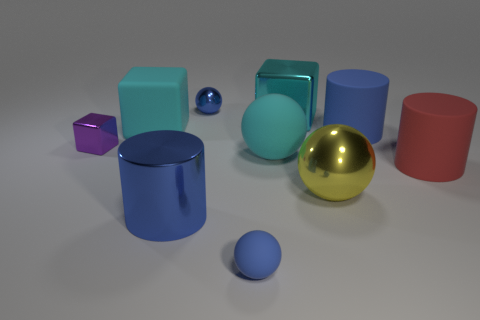What is the size of the shiny thing that is the same color as the big metallic cylinder?
Ensure brevity in your answer.  Small. There is another matte cylinder that is the same size as the red rubber cylinder; what color is it?
Keep it short and to the point. Blue. Does the cyan matte block have the same size as the rubber cylinder behind the red thing?
Ensure brevity in your answer.  Yes. How many large things are the same color as the large shiny ball?
Offer a very short reply. 0. What number of objects are either small gray cylinders or big cylinders to the left of the cyan ball?
Your response must be concise. 1. There is a cylinder behind the big red object; is it the same size as the metallic ball to the right of the large cyan metal thing?
Offer a terse response. Yes. Is there a purple cube made of the same material as the big yellow sphere?
Keep it short and to the point. Yes. There is a yellow shiny object; what shape is it?
Offer a very short reply. Sphere. There is a blue object that is on the right side of the blue sphere in front of the purple metal thing; what shape is it?
Your answer should be very brief. Cylinder. What number of other things are there of the same shape as the small purple object?
Your response must be concise. 2. 